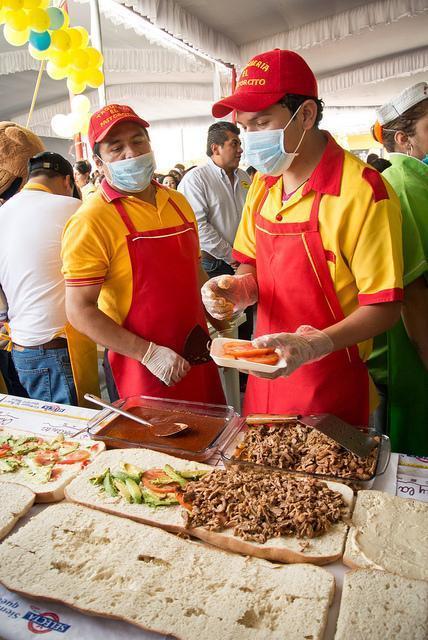How many people are there?
Give a very brief answer. 5. 